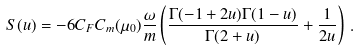Convert formula to latex. <formula><loc_0><loc_0><loc_500><loc_500>S ( u ) = - 6 C _ { F } C _ { m } ( \mu _ { 0 } ) \frac { \omega } { m } \left ( \frac { \Gamma ( - 1 + 2 u ) \Gamma ( 1 - u ) } { \Gamma ( 2 + u ) } + \frac { 1 } { 2 u } \right ) \, .</formula> 